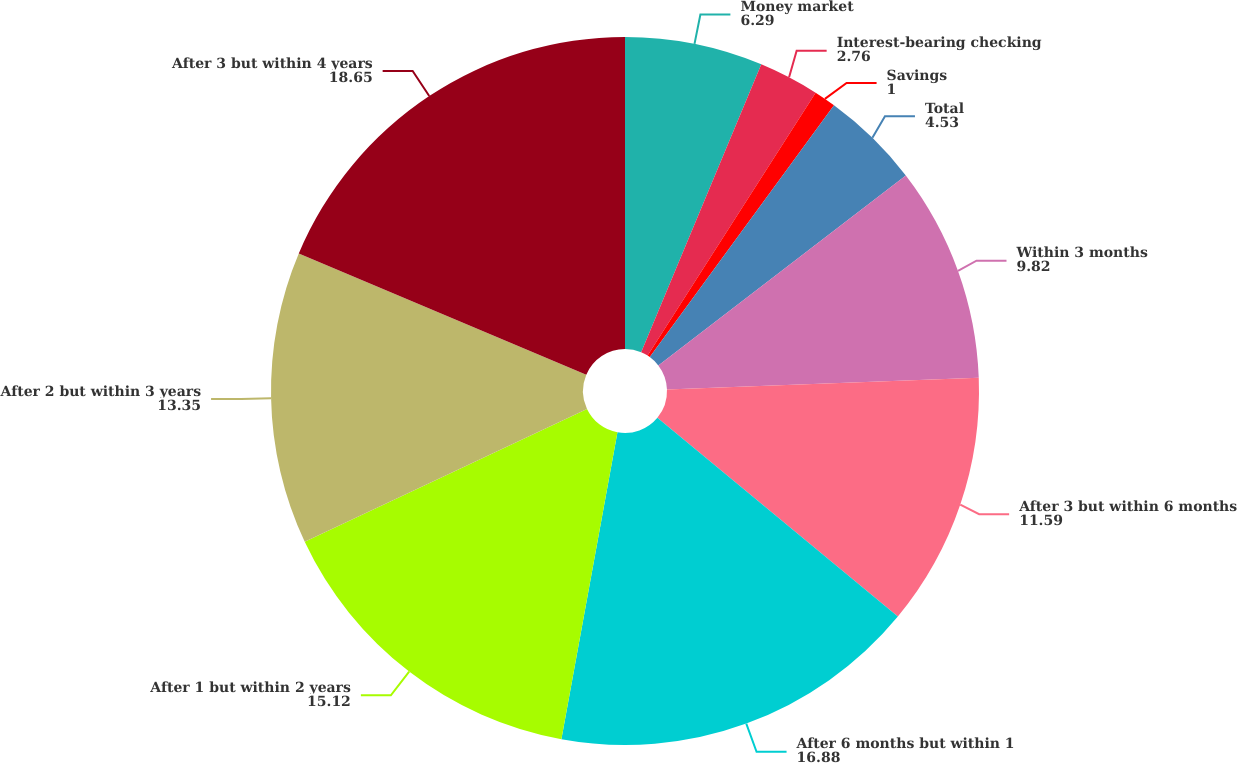Convert chart. <chart><loc_0><loc_0><loc_500><loc_500><pie_chart><fcel>Money market<fcel>Interest-bearing checking<fcel>Savings<fcel>Total<fcel>Within 3 months<fcel>After 3 but within 6 months<fcel>After 6 months but within 1<fcel>After 1 but within 2 years<fcel>After 2 but within 3 years<fcel>After 3 but within 4 years<nl><fcel>6.29%<fcel>2.76%<fcel>1.0%<fcel>4.53%<fcel>9.82%<fcel>11.59%<fcel>16.88%<fcel>15.12%<fcel>13.35%<fcel>18.65%<nl></chart> 